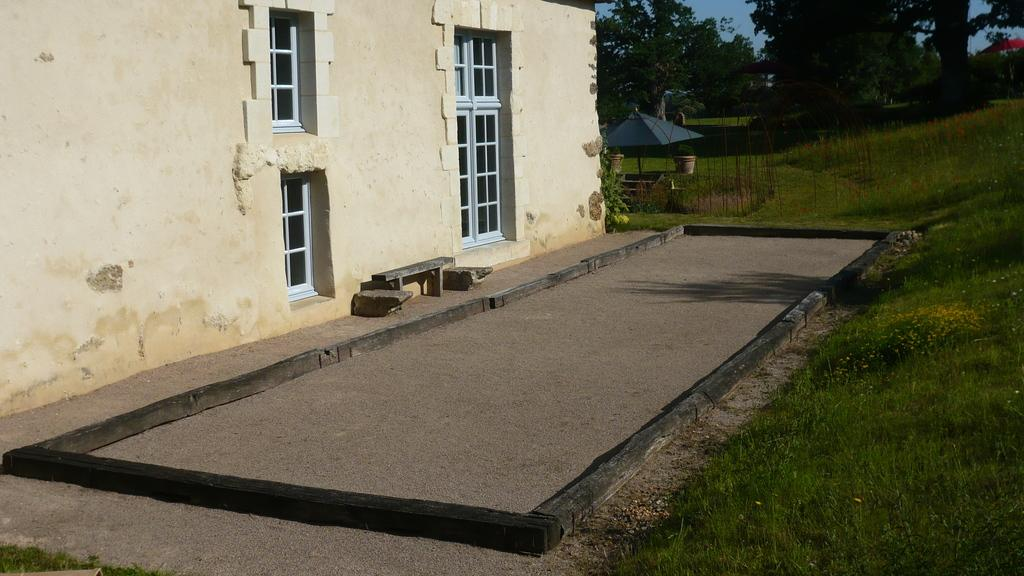What is located on the left side of the image? There is a bench, stones, and a building on the left side of the image. What is present on the right side of the image? There is a tent, trees, plants, and grass on the right side of the image. What can be seen in the background of the image? The sky is visible in the background of the image. Where is the secretary sitting in the image? There is no secretary present in the image. What type of sponge can be seen in the image? There is no sponge present in the image. 